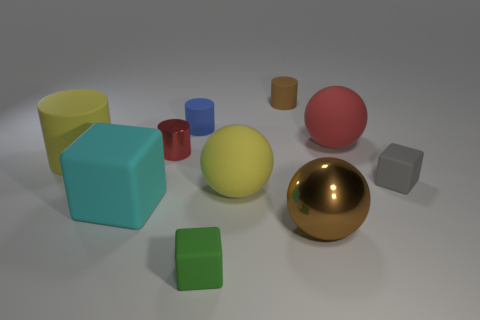There is a object that is the same color as the shiny ball; what size is it? The object sharing the same color as the shiny gold ball appears to be a cylinder, and its size is smaller in comparison to the ball. Specifically, it looks to be about half the height and significantly narrower in diameter. 